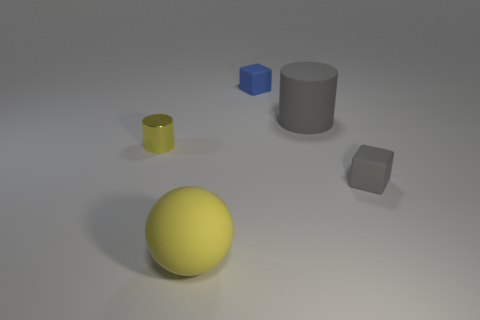Add 1 big cubes. How many objects exist? 6 Subtract all blocks. How many objects are left? 3 Subtract 0 purple spheres. How many objects are left? 5 Subtract all large brown shiny cylinders. Subtract all large rubber cylinders. How many objects are left? 4 Add 4 yellow objects. How many yellow objects are left? 6 Add 2 big yellow rubber things. How many big yellow rubber things exist? 3 